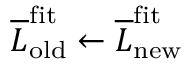<formula> <loc_0><loc_0><loc_500><loc_500>\overline { L } _ { o l d } ^ { f i t } \leftarrow \overline { L } _ { n e w } ^ { f i t }</formula> 